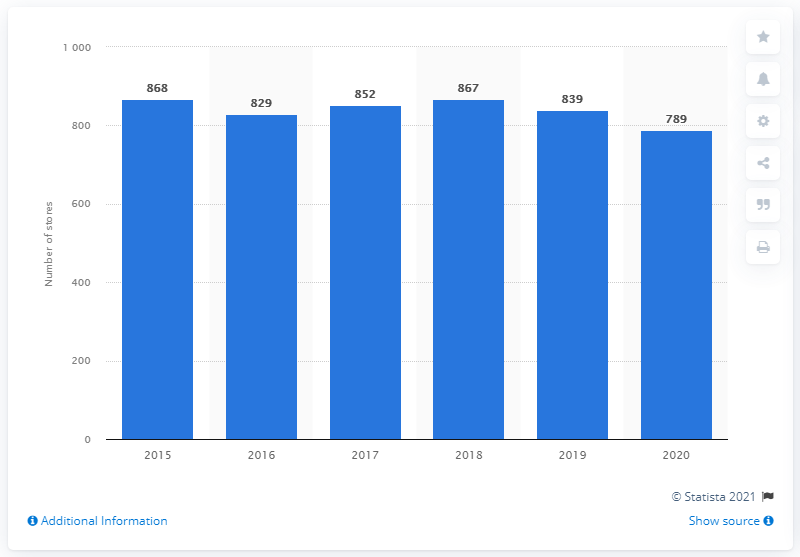Identify some key points in this picture. In 2020, Macy's had 789 stores. 